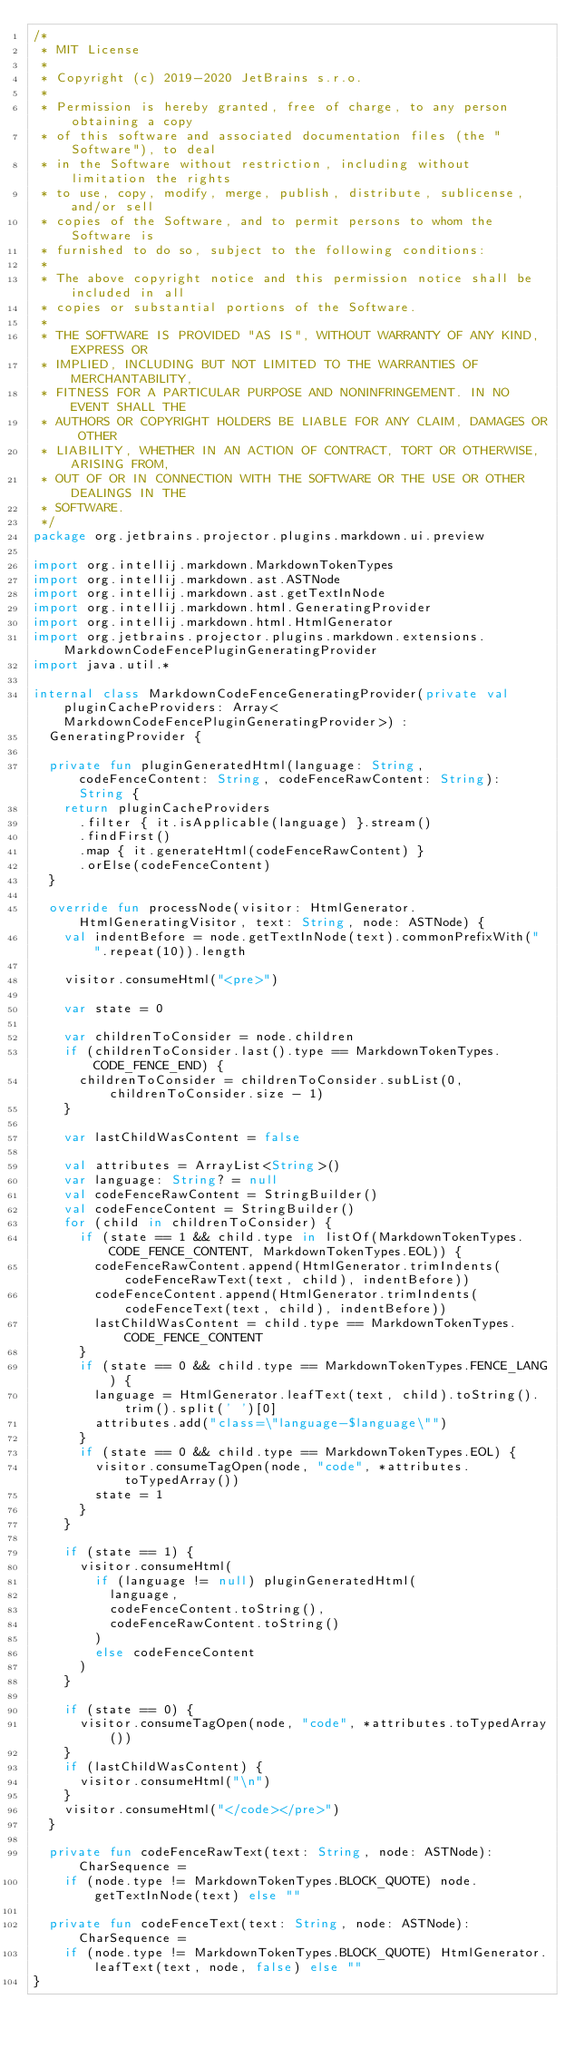<code> <loc_0><loc_0><loc_500><loc_500><_Kotlin_>/*
 * MIT License
 *
 * Copyright (c) 2019-2020 JetBrains s.r.o.
 *
 * Permission is hereby granted, free of charge, to any person obtaining a copy
 * of this software and associated documentation files (the "Software"), to deal
 * in the Software without restriction, including without limitation the rights
 * to use, copy, modify, merge, publish, distribute, sublicense, and/or sell
 * copies of the Software, and to permit persons to whom the Software is
 * furnished to do so, subject to the following conditions:
 *
 * The above copyright notice and this permission notice shall be included in all
 * copies or substantial portions of the Software.
 *
 * THE SOFTWARE IS PROVIDED "AS IS", WITHOUT WARRANTY OF ANY KIND, EXPRESS OR
 * IMPLIED, INCLUDING BUT NOT LIMITED TO THE WARRANTIES OF MERCHANTABILITY,
 * FITNESS FOR A PARTICULAR PURPOSE AND NONINFRINGEMENT. IN NO EVENT SHALL THE
 * AUTHORS OR COPYRIGHT HOLDERS BE LIABLE FOR ANY CLAIM, DAMAGES OR OTHER
 * LIABILITY, WHETHER IN AN ACTION OF CONTRACT, TORT OR OTHERWISE, ARISING FROM,
 * OUT OF OR IN CONNECTION WITH THE SOFTWARE OR THE USE OR OTHER DEALINGS IN THE
 * SOFTWARE.
 */
package org.jetbrains.projector.plugins.markdown.ui.preview

import org.intellij.markdown.MarkdownTokenTypes
import org.intellij.markdown.ast.ASTNode
import org.intellij.markdown.ast.getTextInNode
import org.intellij.markdown.html.GeneratingProvider
import org.intellij.markdown.html.HtmlGenerator
import org.jetbrains.projector.plugins.markdown.extensions.MarkdownCodeFencePluginGeneratingProvider
import java.util.*

internal class MarkdownCodeFenceGeneratingProvider(private val pluginCacheProviders: Array<MarkdownCodeFencePluginGeneratingProvider>) :
  GeneratingProvider {

  private fun pluginGeneratedHtml(language: String, codeFenceContent: String, codeFenceRawContent: String): String {
    return pluginCacheProviders
      .filter { it.isApplicable(language) }.stream()
      .findFirst()
      .map { it.generateHtml(codeFenceRawContent) }
      .orElse(codeFenceContent)
  }

  override fun processNode(visitor: HtmlGenerator.HtmlGeneratingVisitor, text: String, node: ASTNode) {
    val indentBefore = node.getTextInNode(text).commonPrefixWith(" ".repeat(10)).length

    visitor.consumeHtml("<pre>")

    var state = 0

    var childrenToConsider = node.children
    if (childrenToConsider.last().type == MarkdownTokenTypes.CODE_FENCE_END) {
      childrenToConsider = childrenToConsider.subList(0, childrenToConsider.size - 1)
    }

    var lastChildWasContent = false

    val attributes = ArrayList<String>()
    var language: String? = null
    val codeFenceRawContent = StringBuilder()
    val codeFenceContent = StringBuilder()
    for (child in childrenToConsider) {
      if (state == 1 && child.type in listOf(MarkdownTokenTypes.CODE_FENCE_CONTENT, MarkdownTokenTypes.EOL)) {
        codeFenceRawContent.append(HtmlGenerator.trimIndents(codeFenceRawText(text, child), indentBefore))
        codeFenceContent.append(HtmlGenerator.trimIndents(codeFenceText(text, child), indentBefore))
        lastChildWasContent = child.type == MarkdownTokenTypes.CODE_FENCE_CONTENT
      }
      if (state == 0 && child.type == MarkdownTokenTypes.FENCE_LANG) {
        language = HtmlGenerator.leafText(text, child).toString().trim().split(' ')[0]
        attributes.add("class=\"language-$language\"")
      }
      if (state == 0 && child.type == MarkdownTokenTypes.EOL) {
        visitor.consumeTagOpen(node, "code", *attributes.toTypedArray())
        state = 1
      }
    }

    if (state == 1) {
      visitor.consumeHtml(
        if (language != null) pluginGeneratedHtml(
          language,
          codeFenceContent.toString(),
          codeFenceRawContent.toString()
        )
        else codeFenceContent
      )
    }

    if (state == 0) {
      visitor.consumeTagOpen(node, "code", *attributes.toTypedArray())
    }
    if (lastChildWasContent) {
      visitor.consumeHtml("\n")
    }
    visitor.consumeHtml("</code></pre>")
  }

  private fun codeFenceRawText(text: String, node: ASTNode): CharSequence =
    if (node.type != MarkdownTokenTypes.BLOCK_QUOTE) node.getTextInNode(text) else ""

  private fun codeFenceText(text: String, node: ASTNode): CharSequence =
    if (node.type != MarkdownTokenTypes.BLOCK_QUOTE) HtmlGenerator.leafText(text, node, false) else ""
}
</code> 